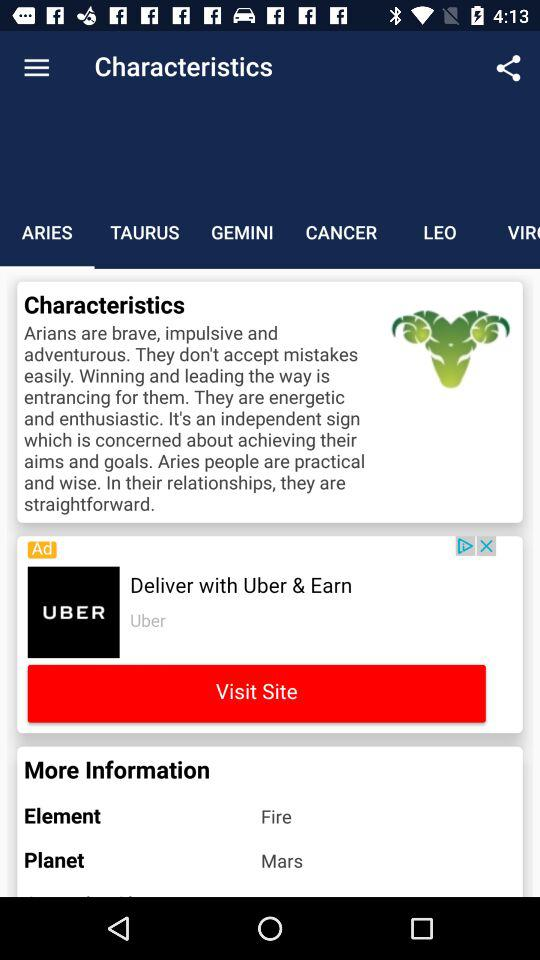What planet is mentioned for Aries? The mentioned planet is Mars. 